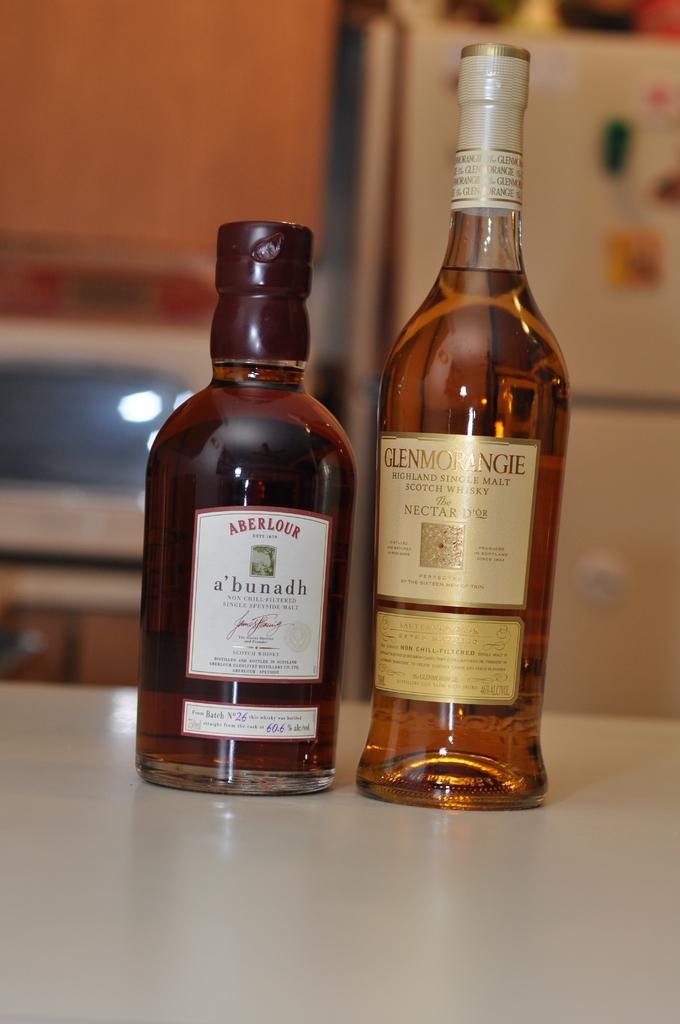What is the brand of alcohol on the right?
Give a very brief answer. Glenmorangie. 